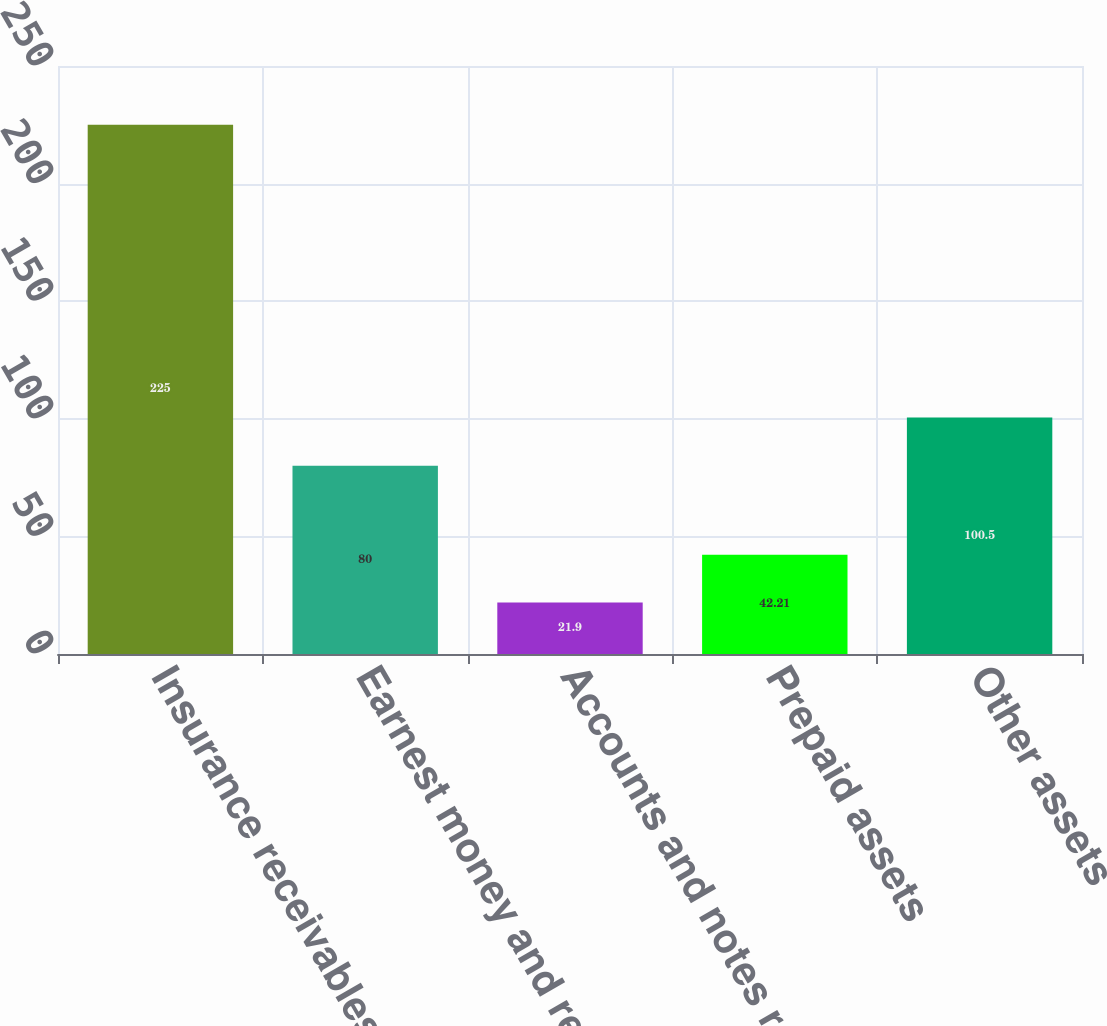<chart> <loc_0><loc_0><loc_500><loc_500><bar_chart><fcel>Insurance receivables<fcel>Earnest money and refundable<fcel>Accounts and notes receivable<fcel>Prepaid assets<fcel>Other assets<nl><fcel>225<fcel>80<fcel>21.9<fcel>42.21<fcel>100.5<nl></chart> 